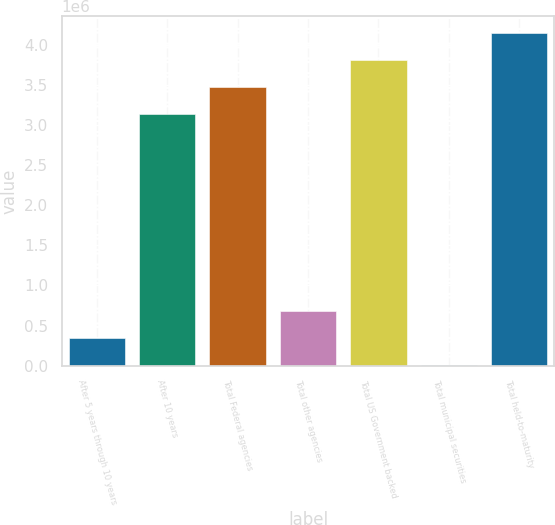Convert chart to OTSL. <chart><loc_0><loc_0><loc_500><loc_500><bar_chart><fcel>After 5 years through 10 years<fcel>After 10 years<fcel>Total Federal agencies<fcel>Total other agencies<fcel>Total US Government backed<fcel>Total municipal securities<fcel>Total held-to-maturity<nl><fcel>345173<fcel>3.13646e+06<fcel>3.47365e+06<fcel>682366<fcel>3.81084e+06<fcel>7981<fcel>4.14804e+06<nl></chart> 